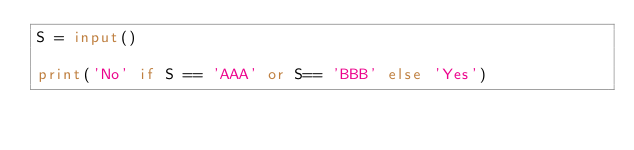Convert code to text. <code><loc_0><loc_0><loc_500><loc_500><_Python_>S = input()

print('No' if S == 'AAA' or S== 'BBB' else 'Yes')
</code> 